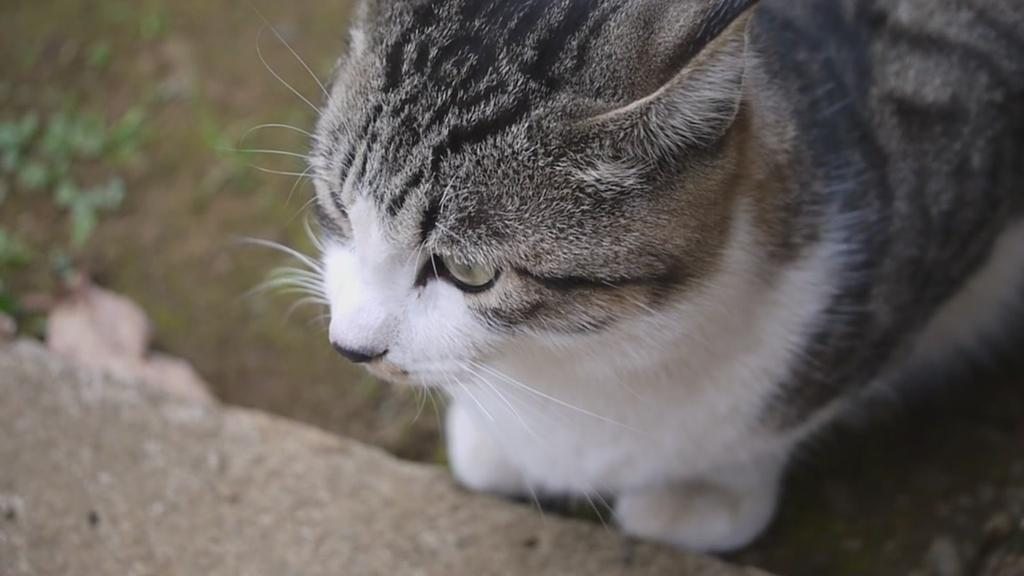What type of animal is in the image? There is a cat in the image. What object can be seen at the bottom of the image? There is a rock at the bottom of the image. What is visible beneath the cat and the rock? The ground is visible in the image. What type of haircut does the cat have in the image? The image does not show the cat's haircut, as it is not relevant to the image. 